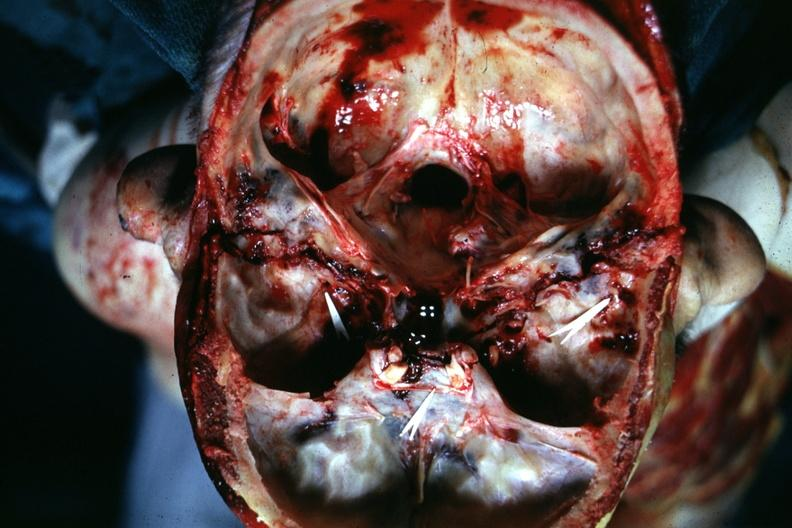s bone, calvarium present?
Answer the question using a single word or phrase. Yes 